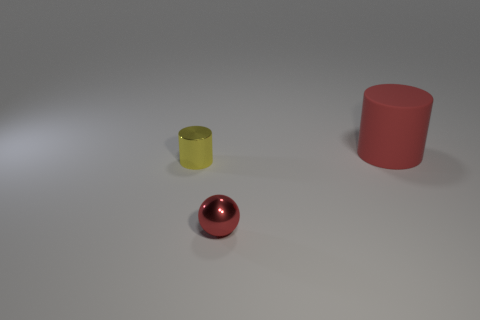Add 3 small yellow metal objects. How many objects exist? 6 Subtract all spheres. How many objects are left? 2 Add 2 big blue matte cylinders. How many big blue matte cylinders exist? 2 Subtract 0 gray blocks. How many objects are left? 3 Subtract all metal cylinders. Subtract all small blue things. How many objects are left? 2 Add 1 tiny cylinders. How many tiny cylinders are left? 2 